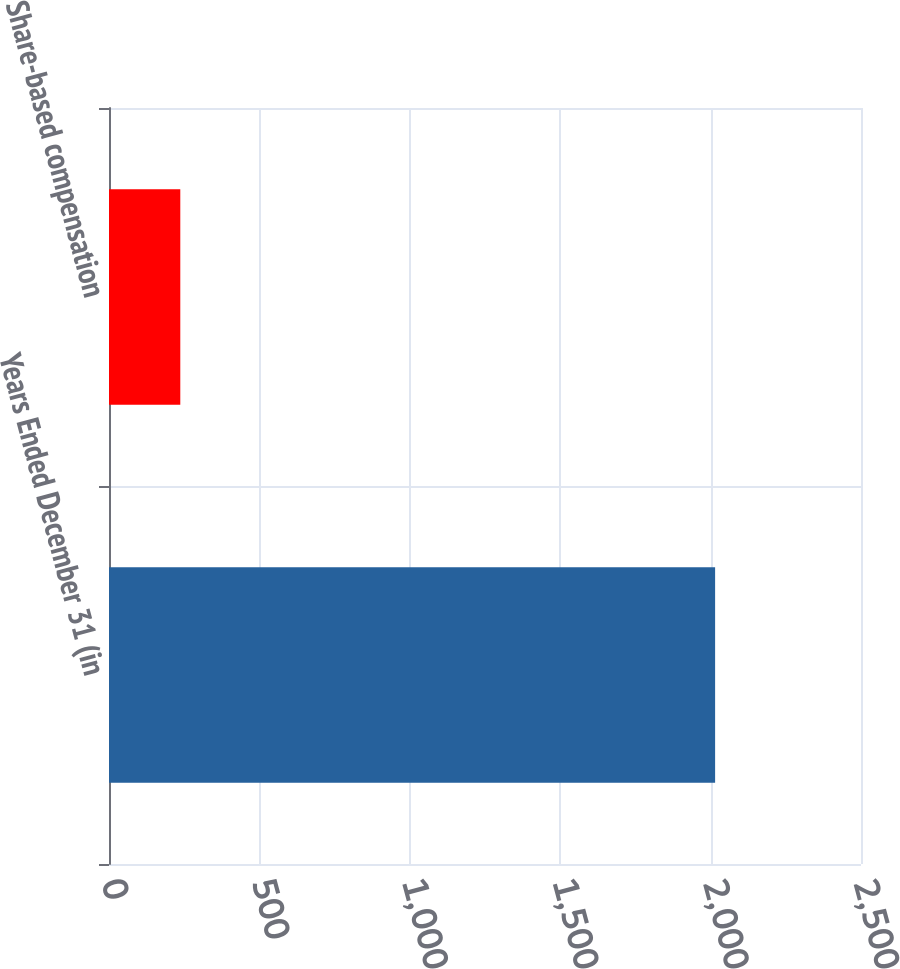<chart> <loc_0><loc_0><loc_500><loc_500><bar_chart><fcel>Years Ended December 31 (in<fcel>Share-based compensation<nl><fcel>2015<fcel>237<nl></chart> 